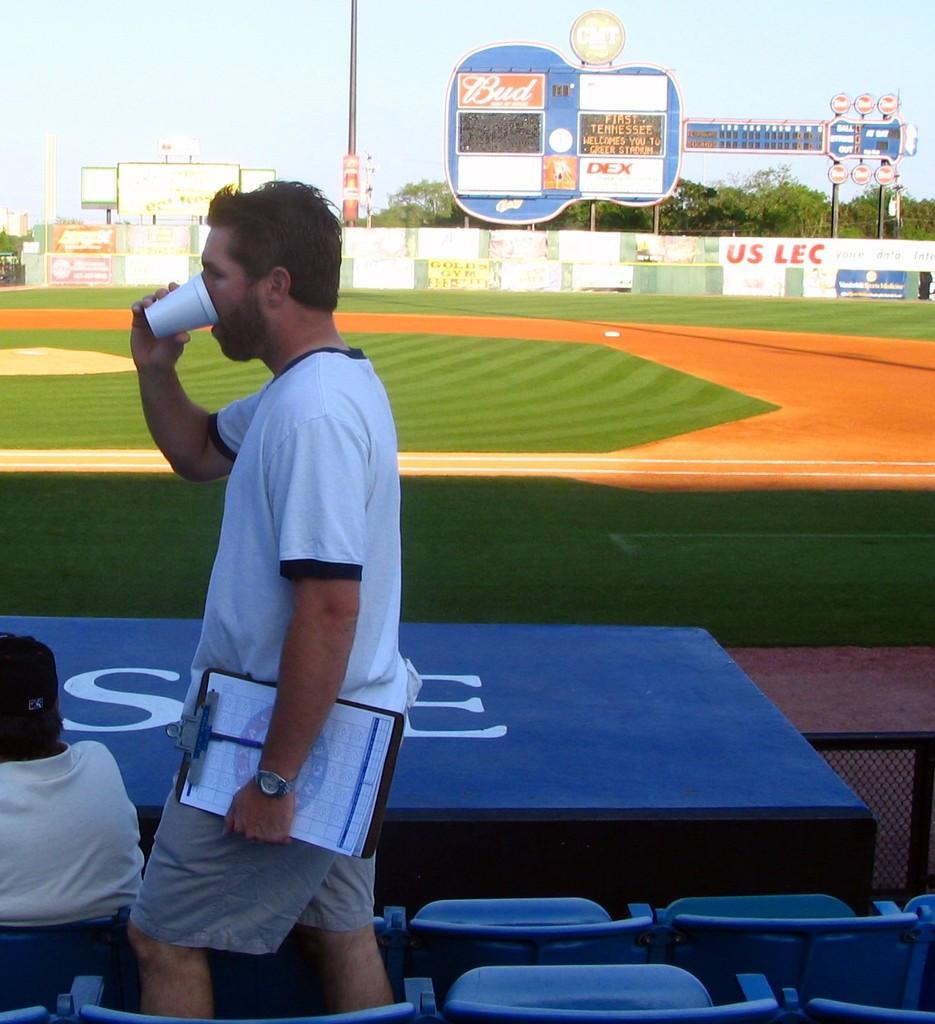<image>
Describe the image concisely. A man carrying a clipboard drinks from a coffee cup with an advertisement for Bud in the background. 